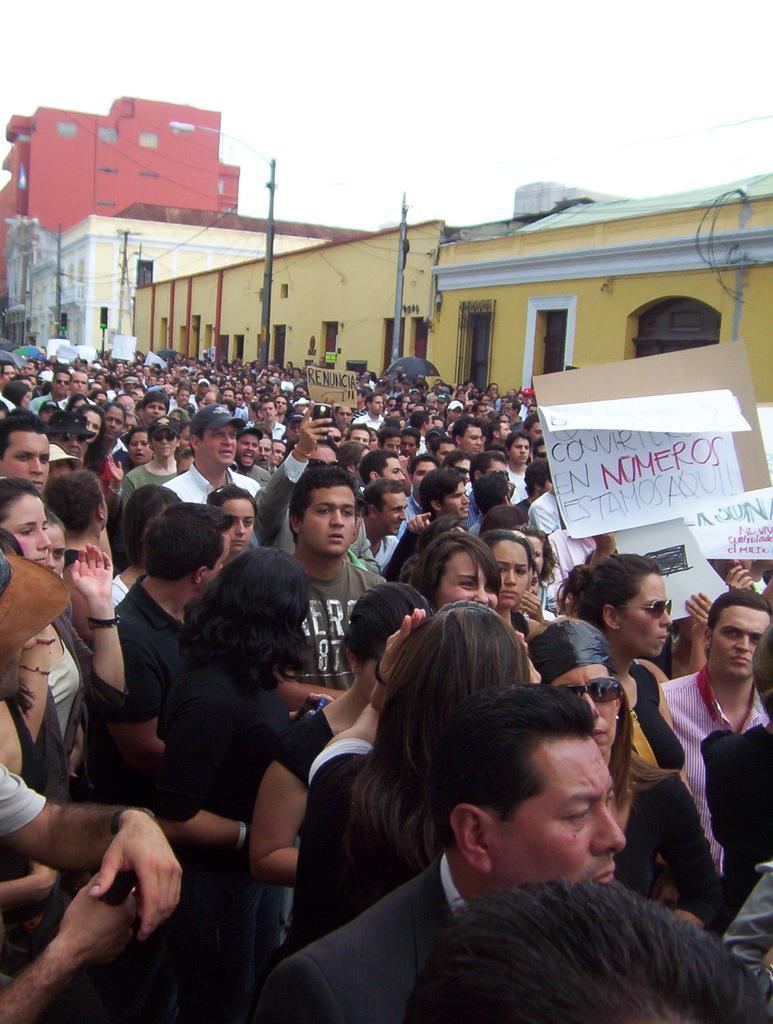Could you give a brief overview of what you see in this image? In this picture there are group of persons standing where few among them are holding card boards which has something written on it and there are buildings in the background. 